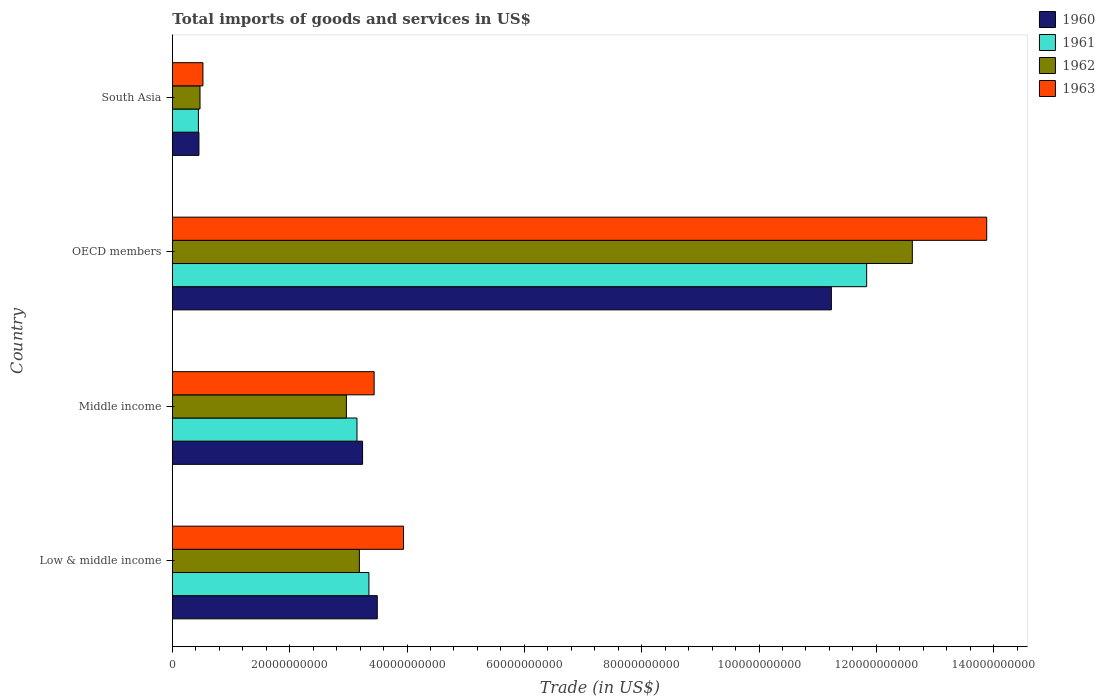How many groups of bars are there?
Ensure brevity in your answer.  4. Are the number of bars per tick equal to the number of legend labels?
Keep it short and to the point. Yes. How many bars are there on the 3rd tick from the bottom?
Provide a short and direct response. 4. What is the label of the 4th group of bars from the top?
Offer a terse response. Low & middle income. What is the total imports of goods and services in 1960 in Middle income?
Your response must be concise. 3.24e+1. Across all countries, what is the maximum total imports of goods and services in 1962?
Provide a short and direct response. 1.26e+11. Across all countries, what is the minimum total imports of goods and services in 1962?
Give a very brief answer. 4.71e+09. What is the total total imports of goods and services in 1961 in the graph?
Ensure brevity in your answer.  1.88e+11. What is the difference between the total imports of goods and services in 1961 in Low & middle income and that in Middle income?
Offer a very short reply. 2.04e+09. What is the difference between the total imports of goods and services in 1960 in OECD members and the total imports of goods and services in 1961 in Low & middle income?
Make the answer very short. 7.88e+1. What is the average total imports of goods and services in 1962 per country?
Your answer should be very brief. 4.81e+1. What is the difference between the total imports of goods and services in 1962 and total imports of goods and services in 1963 in Low & middle income?
Offer a very short reply. -7.52e+09. In how many countries, is the total imports of goods and services in 1963 greater than 88000000000 US$?
Your answer should be very brief. 1. What is the ratio of the total imports of goods and services in 1962 in Middle income to that in OECD members?
Make the answer very short. 0.24. Is the difference between the total imports of goods and services in 1962 in Middle income and South Asia greater than the difference between the total imports of goods and services in 1963 in Middle income and South Asia?
Offer a very short reply. No. What is the difference between the highest and the second highest total imports of goods and services in 1961?
Offer a very short reply. 8.48e+1. What is the difference between the highest and the lowest total imports of goods and services in 1961?
Your answer should be very brief. 1.14e+11. In how many countries, is the total imports of goods and services in 1960 greater than the average total imports of goods and services in 1960 taken over all countries?
Your answer should be compact. 1. Is the sum of the total imports of goods and services in 1962 in Low & middle income and OECD members greater than the maximum total imports of goods and services in 1961 across all countries?
Provide a succinct answer. Yes. What does the 1st bar from the top in Low & middle income represents?
Make the answer very short. 1963. What does the 4th bar from the bottom in South Asia represents?
Ensure brevity in your answer.  1963. Are all the bars in the graph horizontal?
Your answer should be compact. Yes. How many countries are there in the graph?
Your answer should be very brief. 4. Are the values on the major ticks of X-axis written in scientific E-notation?
Ensure brevity in your answer.  No. Does the graph contain any zero values?
Your answer should be very brief. No. Where does the legend appear in the graph?
Your answer should be compact. Top right. What is the title of the graph?
Your answer should be compact. Total imports of goods and services in US$. Does "1969" appear as one of the legend labels in the graph?
Your answer should be very brief. No. What is the label or title of the X-axis?
Make the answer very short. Trade (in US$). What is the Trade (in US$) of 1960 in Low & middle income?
Keep it short and to the point. 3.49e+1. What is the Trade (in US$) of 1961 in Low & middle income?
Keep it short and to the point. 3.35e+1. What is the Trade (in US$) in 1962 in Low & middle income?
Your response must be concise. 3.19e+1. What is the Trade (in US$) of 1963 in Low & middle income?
Your answer should be compact. 3.94e+1. What is the Trade (in US$) of 1960 in Middle income?
Make the answer very short. 3.24e+1. What is the Trade (in US$) in 1961 in Middle income?
Offer a very short reply. 3.15e+1. What is the Trade (in US$) in 1962 in Middle income?
Your response must be concise. 2.97e+1. What is the Trade (in US$) in 1963 in Middle income?
Your response must be concise. 3.44e+1. What is the Trade (in US$) of 1960 in OECD members?
Make the answer very short. 1.12e+11. What is the Trade (in US$) in 1961 in OECD members?
Your answer should be compact. 1.18e+11. What is the Trade (in US$) of 1962 in OECD members?
Give a very brief answer. 1.26e+11. What is the Trade (in US$) in 1963 in OECD members?
Offer a very short reply. 1.39e+11. What is the Trade (in US$) in 1960 in South Asia?
Give a very brief answer. 4.53e+09. What is the Trade (in US$) in 1961 in South Asia?
Keep it short and to the point. 4.43e+09. What is the Trade (in US$) in 1962 in South Asia?
Give a very brief answer. 4.71e+09. What is the Trade (in US$) in 1963 in South Asia?
Offer a very short reply. 5.21e+09. Across all countries, what is the maximum Trade (in US$) of 1960?
Offer a very short reply. 1.12e+11. Across all countries, what is the maximum Trade (in US$) of 1961?
Your answer should be compact. 1.18e+11. Across all countries, what is the maximum Trade (in US$) of 1962?
Give a very brief answer. 1.26e+11. Across all countries, what is the maximum Trade (in US$) in 1963?
Keep it short and to the point. 1.39e+11. Across all countries, what is the minimum Trade (in US$) in 1960?
Your answer should be compact. 4.53e+09. Across all countries, what is the minimum Trade (in US$) in 1961?
Offer a terse response. 4.43e+09. Across all countries, what is the minimum Trade (in US$) of 1962?
Your response must be concise. 4.71e+09. Across all countries, what is the minimum Trade (in US$) in 1963?
Ensure brevity in your answer.  5.21e+09. What is the total Trade (in US$) in 1960 in the graph?
Your answer should be compact. 1.84e+11. What is the total Trade (in US$) in 1961 in the graph?
Keep it short and to the point. 1.88e+11. What is the total Trade (in US$) in 1962 in the graph?
Make the answer very short. 1.92e+11. What is the total Trade (in US$) in 1963 in the graph?
Give a very brief answer. 2.18e+11. What is the difference between the Trade (in US$) in 1960 in Low & middle income and that in Middle income?
Your answer should be compact. 2.50e+09. What is the difference between the Trade (in US$) in 1961 in Low & middle income and that in Middle income?
Give a very brief answer. 2.04e+09. What is the difference between the Trade (in US$) in 1962 in Low & middle income and that in Middle income?
Provide a succinct answer. 2.21e+09. What is the difference between the Trade (in US$) in 1963 in Low & middle income and that in Middle income?
Provide a short and direct response. 5.01e+09. What is the difference between the Trade (in US$) of 1960 in Low & middle income and that in OECD members?
Provide a succinct answer. -7.74e+1. What is the difference between the Trade (in US$) of 1961 in Low & middle income and that in OECD members?
Keep it short and to the point. -8.48e+1. What is the difference between the Trade (in US$) of 1962 in Low & middle income and that in OECD members?
Your response must be concise. -9.43e+1. What is the difference between the Trade (in US$) of 1963 in Low & middle income and that in OECD members?
Provide a succinct answer. -9.94e+1. What is the difference between the Trade (in US$) in 1960 in Low & middle income and that in South Asia?
Give a very brief answer. 3.04e+1. What is the difference between the Trade (in US$) of 1961 in Low & middle income and that in South Asia?
Provide a short and direct response. 2.91e+1. What is the difference between the Trade (in US$) of 1962 in Low & middle income and that in South Asia?
Provide a short and direct response. 2.72e+1. What is the difference between the Trade (in US$) of 1963 in Low & middle income and that in South Asia?
Make the answer very short. 3.42e+1. What is the difference between the Trade (in US$) of 1960 in Middle income and that in OECD members?
Give a very brief answer. -7.99e+1. What is the difference between the Trade (in US$) of 1961 in Middle income and that in OECD members?
Your response must be concise. -8.69e+1. What is the difference between the Trade (in US$) in 1962 in Middle income and that in OECD members?
Your answer should be compact. -9.65e+1. What is the difference between the Trade (in US$) of 1963 in Middle income and that in OECD members?
Give a very brief answer. -1.04e+11. What is the difference between the Trade (in US$) of 1960 in Middle income and that in South Asia?
Provide a succinct answer. 2.79e+1. What is the difference between the Trade (in US$) of 1961 in Middle income and that in South Asia?
Your answer should be very brief. 2.70e+1. What is the difference between the Trade (in US$) in 1962 in Middle income and that in South Asia?
Offer a very short reply. 2.50e+1. What is the difference between the Trade (in US$) of 1963 in Middle income and that in South Asia?
Offer a terse response. 2.92e+1. What is the difference between the Trade (in US$) of 1960 in OECD members and that in South Asia?
Your answer should be very brief. 1.08e+11. What is the difference between the Trade (in US$) of 1961 in OECD members and that in South Asia?
Provide a succinct answer. 1.14e+11. What is the difference between the Trade (in US$) in 1962 in OECD members and that in South Asia?
Offer a very short reply. 1.21e+11. What is the difference between the Trade (in US$) in 1963 in OECD members and that in South Asia?
Offer a very short reply. 1.34e+11. What is the difference between the Trade (in US$) in 1960 in Low & middle income and the Trade (in US$) in 1961 in Middle income?
Your answer should be very brief. 3.46e+09. What is the difference between the Trade (in US$) of 1960 in Low & middle income and the Trade (in US$) of 1962 in Middle income?
Your response must be concise. 5.26e+09. What is the difference between the Trade (in US$) in 1960 in Low & middle income and the Trade (in US$) in 1963 in Middle income?
Offer a very short reply. 5.30e+08. What is the difference between the Trade (in US$) in 1961 in Low & middle income and the Trade (in US$) in 1962 in Middle income?
Offer a terse response. 3.84e+09. What is the difference between the Trade (in US$) of 1961 in Low & middle income and the Trade (in US$) of 1963 in Middle income?
Keep it short and to the point. -8.90e+08. What is the difference between the Trade (in US$) of 1962 in Low & middle income and the Trade (in US$) of 1963 in Middle income?
Offer a terse response. -2.51e+09. What is the difference between the Trade (in US$) of 1960 in Low & middle income and the Trade (in US$) of 1961 in OECD members?
Your response must be concise. -8.34e+1. What is the difference between the Trade (in US$) in 1960 in Low & middle income and the Trade (in US$) in 1962 in OECD members?
Provide a succinct answer. -9.12e+1. What is the difference between the Trade (in US$) of 1960 in Low & middle income and the Trade (in US$) of 1963 in OECD members?
Your answer should be compact. -1.04e+11. What is the difference between the Trade (in US$) in 1961 in Low & middle income and the Trade (in US$) in 1962 in OECD members?
Offer a very short reply. -9.26e+1. What is the difference between the Trade (in US$) in 1961 in Low & middle income and the Trade (in US$) in 1963 in OECD members?
Offer a very short reply. -1.05e+11. What is the difference between the Trade (in US$) in 1962 in Low & middle income and the Trade (in US$) in 1963 in OECD members?
Offer a terse response. -1.07e+11. What is the difference between the Trade (in US$) of 1960 in Low & middle income and the Trade (in US$) of 1961 in South Asia?
Keep it short and to the point. 3.05e+1. What is the difference between the Trade (in US$) of 1960 in Low & middle income and the Trade (in US$) of 1962 in South Asia?
Provide a succinct answer. 3.02e+1. What is the difference between the Trade (in US$) of 1960 in Low & middle income and the Trade (in US$) of 1963 in South Asia?
Your answer should be very brief. 2.97e+1. What is the difference between the Trade (in US$) in 1961 in Low & middle income and the Trade (in US$) in 1962 in South Asia?
Provide a short and direct response. 2.88e+1. What is the difference between the Trade (in US$) in 1961 in Low & middle income and the Trade (in US$) in 1963 in South Asia?
Make the answer very short. 2.83e+1. What is the difference between the Trade (in US$) of 1962 in Low & middle income and the Trade (in US$) of 1963 in South Asia?
Give a very brief answer. 2.67e+1. What is the difference between the Trade (in US$) in 1960 in Middle income and the Trade (in US$) in 1961 in OECD members?
Your response must be concise. -8.59e+1. What is the difference between the Trade (in US$) of 1960 in Middle income and the Trade (in US$) of 1962 in OECD members?
Offer a very short reply. -9.37e+1. What is the difference between the Trade (in US$) in 1960 in Middle income and the Trade (in US$) in 1963 in OECD members?
Your answer should be very brief. -1.06e+11. What is the difference between the Trade (in US$) in 1961 in Middle income and the Trade (in US$) in 1962 in OECD members?
Provide a short and direct response. -9.47e+1. What is the difference between the Trade (in US$) in 1961 in Middle income and the Trade (in US$) in 1963 in OECD members?
Give a very brief answer. -1.07e+11. What is the difference between the Trade (in US$) of 1962 in Middle income and the Trade (in US$) of 1963 in OECD members?
Offer a very short reply. -1.09e+11. What is the difference between the Trade (in US$) in 1960 in Middle income and the Trade (in US$) in 1961 in South Asia?
Provide a short and direct response. 2.80e+1. What is the difference between the Trade (in US$) in 1960 in Middle income and the Trade (in US$) in 1962 in South Asia?
Provide a short and direct response. 2.77e+1. What is the difference between the Trade (in US$) of 1960 in Middle income and the Trade (in US$) of 1963 in South Asia?
Ensure brevity in your answer.  2.72e+1. What is the difference between the Trade (in US$) of 1961 in Middle income and the Trade (in US$) of 1962 in South Asia?
Ensure brevity in your answer.  2.68e+1. What is the difference between the Trade (in US$) of 1961 in Middle income and the Trade (in US$) of 1963 in South Asia?
Give a very brief answer. 2.63e+1. What is the difference between the Trade (in US$) in 1962 in Middle income and the Trade (in US$) in 1963 in South Asia?
Make the answer very short. 2.45e+1. What is the difference between the Trade (in US$) in 1960 in OECD members and the Trade (in US$) in 1961 in South Asia?
Provide a short and direct response. 1.08e+11. What is the difference between the Trade (in US$) of 1960 in OECD members and the Trade (in US$) of 1962 in South Asia?
Give a very brief answer. 1.08e+11. What is the difference between the Trade (in US$) of 1960 in OECD members and the Trade (in US$) of 1963 in South Asia?
Your answer should be very brief. 1.07e+11. What is the difference between the Trade (in US$) of 1961 in OECD members and the Trade (in US$) of 1962 in South Asia?
Your response must be concise. 1.14e+11. What is the difference between the Trade (in US$) of 1961 in OECD members and the Trade (in US$) of 1963 in South Asia?
Give a very brief answer. 1.13e+11. What is the difference between the Trade (in US$) in 1962 in OECD members and the Trade (in US$) in 1963 in South Asia?
Your answer should be very brief. 1.21e+11. What is the average Trade (in US$) of 1960 per country?
Your response must be concise. 4.61e+1. What is the average Trade (in US$) in 1961 per country?
Provide a short and direct response. 4.69e+1. What is the average Trade (in US$) in 1962 per country?
Provide a short and direct response. 4.81e+1. What is the average Trade (in US$) of 1963 per country?
Provide a short and direct response. 5.45e+1. What is the difference between the Trade (in US$) of 1960 and Trade (in US$) of 1961 in Low & middle income?
Offer a terse response. 1.42e+09. What is the difference between the Trade (in US$) in 1960 and Trade (in US$) in 1962 in Low & middle income?
Provide a short and direct response. 3.05e+09. What is the difference between the Trade (in US$) in 1960 and Trade (in US$) in 1963 in Low & middle income?
Ensure brevity in your answer.  -4.48e+09. What is the difference between the Trade (in US$) in 1961 and Trade (in US$) in 1962 in Low & middle income?
Give a very brief answer. 1.62e+09. What is the difference between the Trade (in US$) of 1961 and Trade (in US$) of 1963 in Low & middle income?
Make the answer very short. -5.90e+09. What is the difference between the Trade (in US$) of 1962 and Trade (in US$) of 1963 in Low & middle income?
Ensure brevity in your answer.  -7.52e+09. What is the difference between the Trade (in US$) in 1960 and Trade (in US$) in 1961 in Middle income?
Ensure brevity in your answer.  9.57e+08. What is the difference between the Trade (in US$) in 1960 and Trade (in US$) in 1962 in Middle income?
Your response must be concise. 2.76e+09. What is the difference between the Trade (in US$) of 1960 and Trade (in US$) of 1963 in Middle income?
Provide a short and direct response. -1.97e+09. What is the difference between the Trade (in US$) of 1961 and Trade (in US$) of 1962 in Middle income?
Give a very brief answer. 1.80e+09. What is the difference between the Trade (in US$) in 1961 and Trade (in US$) in 1963 in Middle income?
Offer a terse response. -2.93e+09. What is the difference between the Trade (in US$) of 1962 and Trade (in US$) of 1963 in Middle income?
Your answer should be very brief. -4.73e+09. What is the difference between the Trade (in US$) of 1960 and Trade (in US$) of 1961 in OECD members?
Keep it short and to the point. -6.01e+09. What is the difference between the Trade (in US$) in 1960 and Trade (in US$) in 1962 in OECD members?
Ensure brevity in your answer.  -1.38e+1. What is the difference between the Trade (in US$) in 1960 and Trade (in US$) in 1963 in OECD members?
Your response must be concise. -2.65e+1. What is the difference between the Trade (in US$) in 1961 and Trade (in US$) in 1962 in OECD members?
Your response must be concise. -7.79e+09. What is the difference between the Trade (in US$) of 1961 and Trade (in US$) of 1963 in OECD members?
Your answer should be very brief. -2.05e+1. What is the difference between the Trade (in US$) of 1962 and Trade (in US$) of 1963 in OECD members?
Give a very brief answer. -1.27e+1. What is the difference between the Trade (in US$) in 1960 and Trade (in US$) in 1961 in South Asia?
Offer a very short reply. 9.31e+07. What is the difference between the Trade (in US$) in 1960 and Trade (in US$) in 1962 in South Asia?
Your answer should be compact. -1.84e+08. What is the difference between the Trade (in US$) of 1960 and Trade (in US$) of 1963 in South Asia?
Your response must be concise. -6.84e+08. What is the difference between the Trade (in US$) in 1961 and Trade (in US$) in 1962 in South Asia?
Ensure brevity in your answer.  -2.77e+08. What is the difference between the Trade (in US$) in 1961 and Trade (in US$) in 1963 in South Asia?
Keep it short and to the point. -7.77e+08. What is the difference between the Trade (in US$) in 1962 and Trade (in US$) in 1963 in South Asia?
Offer a very short reply. -5.00e+08. What is the ratio of the Trade (in US$) of 1960 in Low & middle income to that in Middle income?
Provide a succinct answer. 1.08. What is the ratio of the Trade (in US$) in 1961 in Low & middle income to that in Middle income?
Your response must be concise. 1.06. What is the ratio of the Trade (in US$) in 1962 in Low & middle income to that in Middle income?
Offer a terse response. 1.07. What is the ratio of the Trade (in US$) of 1963 in Low & middle income to that in Middle income?
Your answer should be compact. 1.15. What is the ratio of the Trade (in US$) of 1960 in Low & middle income to that in OECD members?
Your answer should be compact. 0.31. What is the ratio of the Trade (in US$) in 1961 in Low & middle income to that in OECD members?
Your answer should be compact. 0.28. What is the ratio of the Trade (in US$) in 1962 in Low & middle income to that in OECD members?
Your answer should be very brief. 0.25. What is the ratio of the Trade (in US$) of 1963 in Low & middle income to that in OECD members?
Your answer should be compact. 0.28. What is the ratio of the Trade (in US$) of 1960 in Low & middle income to that in South Asia?
Provide a short and direct response. 7.71. What is the ratio of the Trade (in US$) of 1961 in Low & middle income to that in South Asia?
Your response must be concise. 7.55. What is the ratio of the Trade (in US$) in 1962 in Low & middle income to that in South Asia?
Provide a succinct answer. 6.77. What is the ratio of the Trade (in US$) of 1963 in Low & middle income to that in South Asia?
Make the answer very short. 7.56. What is the ratio of the Trade (in US$) of 1960 in Middle income to that in OECD members?
Keep it short and to the point. 0.29. What is the ratio of the Trade (in US$) in 1961 in Middle income to that in OECD members?
Offer a very short reply. 0.27. What is the ratio of the Trade (in US$) in 1962 in Middle income to that in OECD members?
Your response must be concise. 0.24. What is the ratio of the Trade (in US$) of 1963 in Middle income to that in OECD members?
Ensure brevity in your answer.  0.25. What is the ratio of the Trade (in US$) in 1960 in Middle income to that in South Asia?
Ensure brevity in your answer.  7.16. What is the ratio of the Trade (in US$) of 1961 in Middle income to that in South Asia?
Offer a terse response. 7.1. What is the ratio of the Trade (in US$) in 1962 in Middle income to that in South Asia?
Keep it short and to the point. 6.3. What is the ratio of the Trade (in US$) in 1963 in Middle income to that in South Asia?
Make the answer very short. 6.6. What is the ratio of the Trade (in US$) of 1960 in OECD members to that in South Asia?
Offer a very short reply. 24.81. What is the ratio of the Trade (in US$) in 1961 in OECD members to that in South Asia?
Your answer should be compact. 26.69. What is the ratio of the Trade (in US$) of 1962 in OECD members to that in South Asia?
Ensure brevity in your answer.  26.77. What is the ratio of the Trade (in US$) in 1963 in OECD members to that in South Asia?
Your response must be concise. 26.63. What is the difference between the highest and the second highest Trade (in US$) in 1960?
Make the answer very short. 7.74e+1. What is the difference between the highest and the second highest Trade (in US$) in 1961?
Provide a short and direct response. 8.48e+1. What is the difference between the highest and the second highest Trade (in US$) of 1962?
Your answer should be very brief. 9.43e+1. What is the difference between the highest and the second highest Trade (in US$) of 1963?
Your answer should be very brief. 9.94e+1. What is the difference between the highest and the lowest Trade (in US$) in 1960?
Offer a terse response. 1.08e+11. What is the difference between the highest and the lowest Trade (in US$) of 1961?
Give a very brief answer. 1.14e+11. What is the difference between the highest and the lowest Trade (in US$) of 1962?
Give a very brief answer. 1.21e+11. What is the difference between the highest and the lowest Trade (in US$) in 1963?
Your answer should be compact. 1.34e+11. 